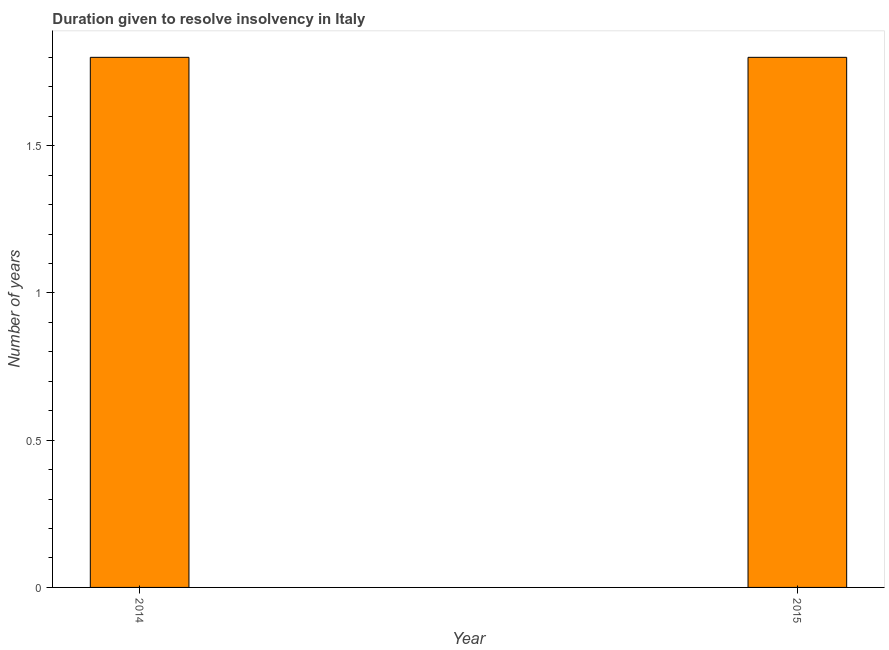What is the title of the graph?
Your answer should be compact. Duration given to resolve insolvency in Italy. What is the label or title of the Y-axis?
Provide a short and direct response. Number of years. Across all years, what is the maximum number of years to resolve insolvency?
Your response must be concise. 1.8. Across all years, what is the minimum number of years to resolve insolvency?
Offer a very short reply. 1.8. In which year was the number of years to resolve insolvency maximum?
Make the answer very short. 2014. What is the sum of the number of years to resolve insolvency?
Provide a succinct answer. 3.6. What is the ratio of the number of years to resolve insolvency in 2014 to that in 2015?
Give a very brief answer. 1. Is the number of years to resolve insolvency in 2014 less than that in 2015?
Ensure brevity in your answer.  No. How many bars are there?
Your answer should be compact. 2. How many years are there in the graph?
Your answer should be very brief. 2. Are the values on the major ticks of Y-axis written in scientific E-notation?
Offer a very short reply. No. What is the difference between the Number of years in 2014 and 2015?
Give a very brief answer. 0. What is the ratio of the Number of years in 2014 to that in 2015?
Ensure brevity in your answer.  1. 